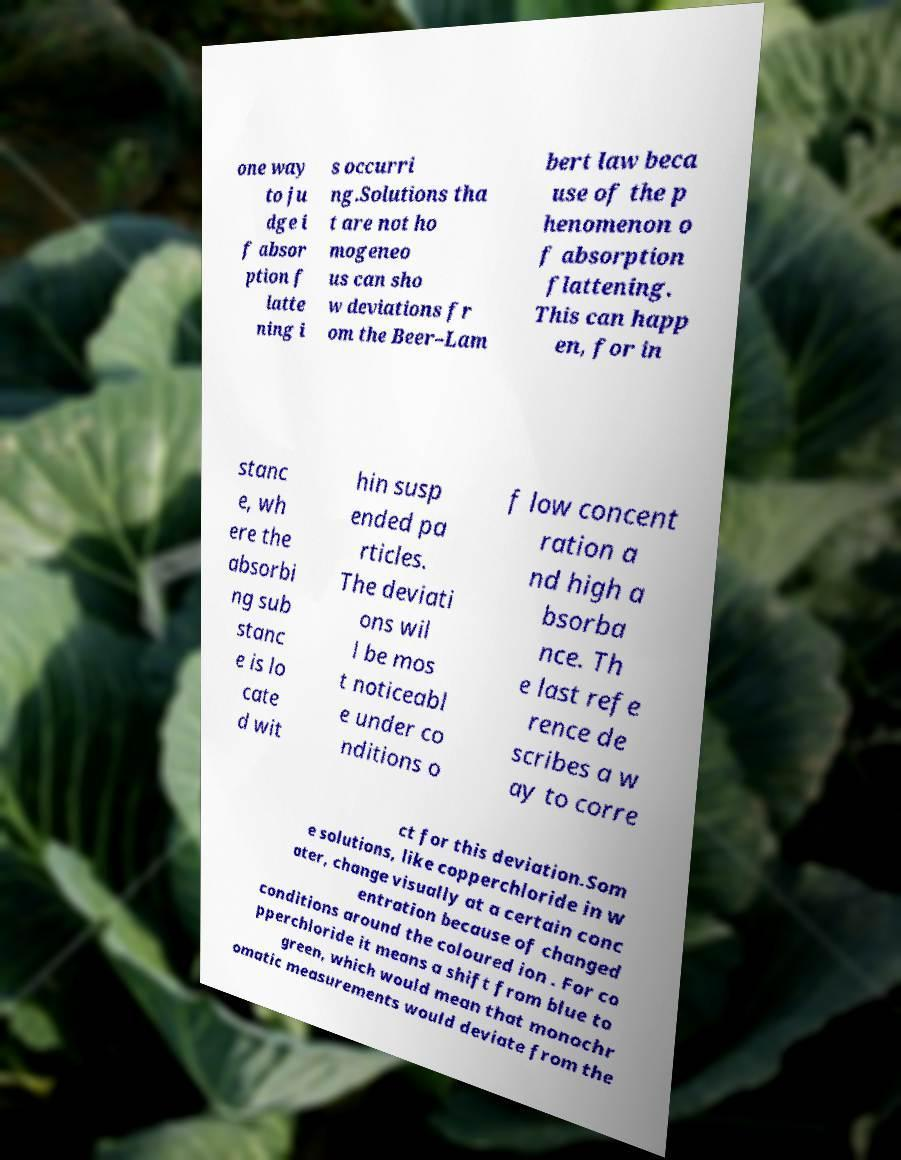For documentation purposes, I need the text within this image transcribed. Could you provide that? one way to ju dge i f absor ption f latte ning i s occurri ng.Solutions tha t are not ho mogeneo us can sho w deviations fr om the Beer–Lam bert law beca use of the p henomenon o f absorption flattening. This can happ en, for in stanc e, wh ere the absorbi ng sub stanc e is lo cate d wit hin susp ended pa rticles. The deviati ons wil l be mos t noticeabl e under co nditions o f low concent ration a nd high a bsorba nce. Th e last refe rence de scribes a w ay to corre ct for this deviation.Som e solutions, like copperchloride in w ater, change visually at a certain conc entration because of changed conditions around the coloured ion . For co pperchloride it means a shift from blue to green, which would mean that monochr omatic measurements would deviate from the 